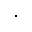<formula> <loc_0><loc_0><loc_500><loc_500>\cdot</formula> 